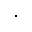<formula> <loc_0><loc_0><loc_500><loc_500>\cdot</formula> 